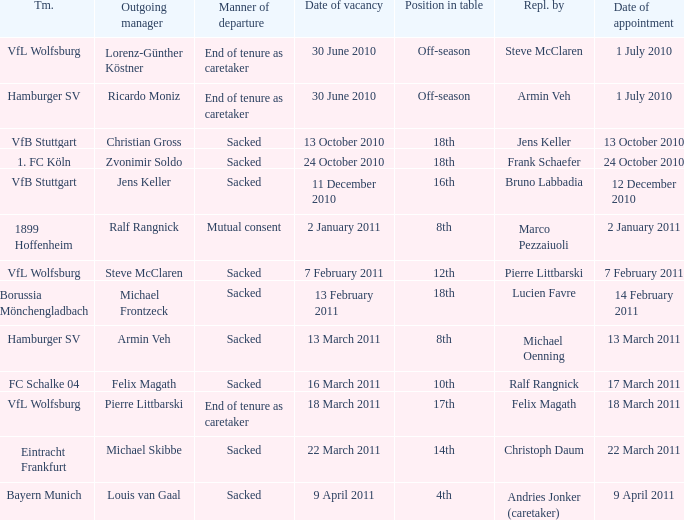Would you mind parsing the complete table? {'header': ['Tm.', 'Outgoing manager', 'Manner of departure', 'Date of vacancy', 'Position in table', 'Repl. by', 'Date of appointment'], 'rows': [['VfL Wolfsburg', 'Lorenz-Günther Köstner', 'End of tenure as caretaker', '30 June 2010', 'Off-season', 'Steve McClaren', '1 July 2010'], ['Hamburger SV', 'Ricardo Moniz', 'End of tenure as caretaker', '30 June 2010', 'Off-season', 'Armin Veh', '1 July 2010'], ['VfB Stuttgart', 'Christian Gross', 'Sacked', '13 October 2010', '18th', 'Jens Keller', '13 October 2010'], ['1. FC Köln', 'Zvonimir Soldo', 'Sacked', '24 October 2010', '18th', 'Frank Schaefer', '24 October 2010'], ['VfB Stuttgart', 'Jens Keller', 'Sacked', '11 December 2010', '16th', 'Bruno Labbadia', '12 December 2010'], ['1899 Hoffenheim', 'Ralf Rangnick', 'Mutual consent', '2 January 2011', '8th', 'Marco Pezzaiuoli', '2 January 2011'], ['VfL Wolfsburg', 'Steve McClaren', 'Sacked', '7 February 2011', '12th', 'Pierre Littbarski', '7 February 2011'], ['Borussia Mönchengladbach', 'Michael Frontzeck', 'Sacked', '13 February 2011', '18th', 'Lucien Favre', '14 February 2011'], ['Hamburger SV', 'Armin Veh', 'Sacked', '13 March 2011', '8th', 'Michael Oenning', '13 March 2011'], ['FC Schalke 04', 'Felix Magath', 'Sacked', '16 March 2011', '10th', 'Ralf Rangnick', '17 March 2011'], ['VfL Wolfsburg', 'Pierre Littbarski', 'End of tenure as caretaker', '18 March 2011', '17th', 'Felix Magath', '18 March 2011'], ['Eintracht Frankfurt', 'Michael Skibbe', 'Sacked', '22 March 2011', '14th', 'Christoph Daum', '22 March 2011'], ['Bayern Munich', 'Louis van Gaal', 'Sacked', '9 April 2011', '4th', 'Andries Jonker (caretaker)', '9 April 2011']]} When steve mcclaren is the replacer what is the manner of departure? End of tenure as caretaker. 